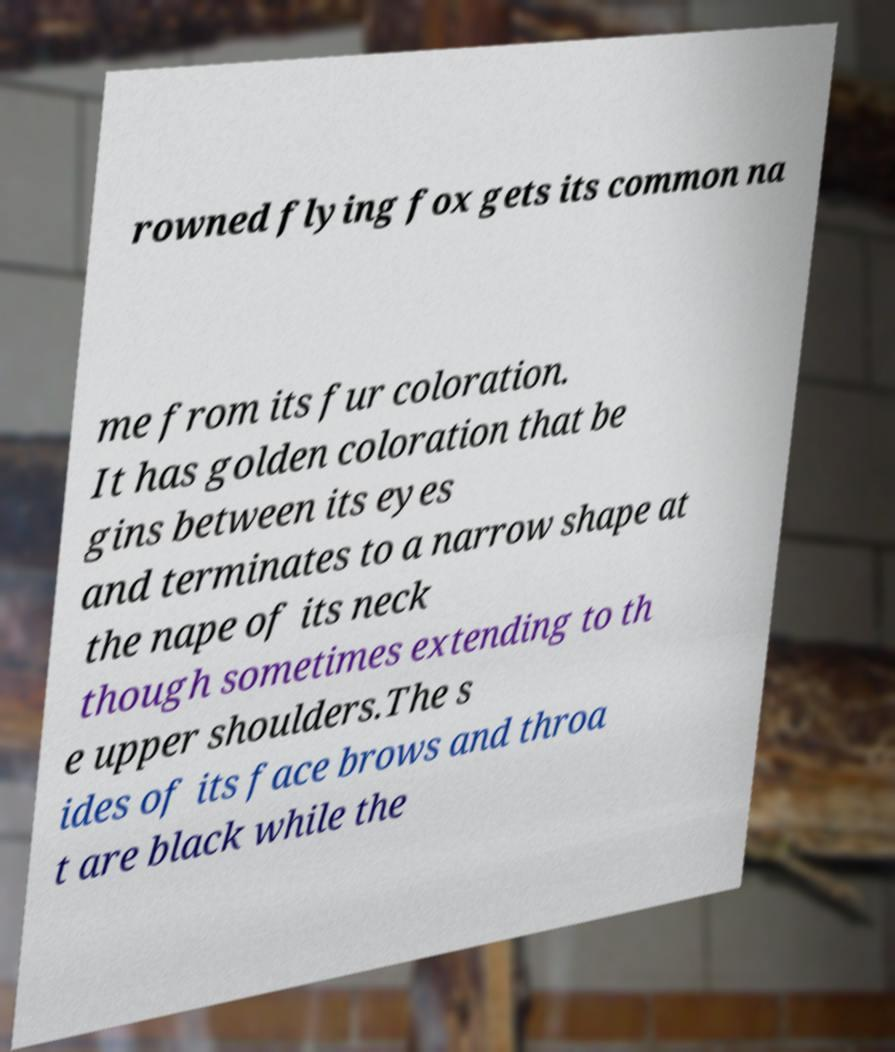Please identify and transcribe the text found in this image. rowned flying fox gets its common na me from its fur coloration. It has golden coloration that be gins between its eyes and terminates to a narrow shape at the nape of its neck though sometimes extending to th e upper shoulders.The s ides of its face brows and throa t are black while the 